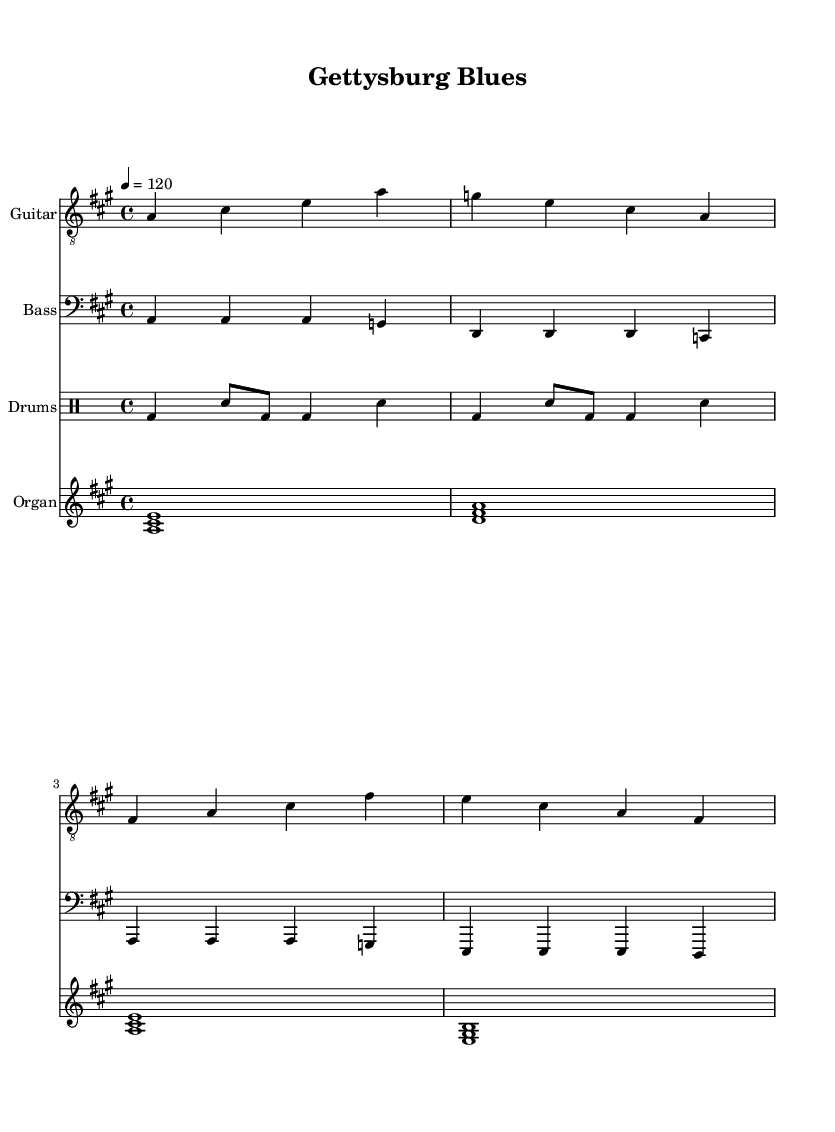What is the key signature of this music? The key signature is A major, which has three sharps: F sharp, C sharp, and G sharp. This is identified by looking at the key signature notation at the beginning of the score.
Answer: A major What is the time signature of this music? The time signature is 4/4, indicated at the beginning of the score. It shows that there are four beats in a measure and the quarter note gets one beat.
Answer: 4/4 What is the tempo marking of this music? The tempo marking is 120 beats per minute, indicated by the tempo text "4 = 120" at the beginning of the score. This refers to the quarter note being played at a speed of 120 beats per minute.
Answer: 120 How many measures are in the guitar part? The guitar part contains 8 measures. This can be counted by examining the stacked vertical lines which denote the end of each measure.
Answer: 8 measures What chord is played in the organ part during the first measure? The chord played is A major, represented by the notes A, C sharp, and E stacked together in the first measure of the organ part. This is identifiable from the notation presented.
Answer: A major Which two military groups are referenced in the lyrics? The lyrics reference Union and Confederate troops, which directly mention the two sides involved in the Battle of Gettysburg. This can be found by reading the provided lyrics beneath the music staff.
Answer: Union and Confederate What type of music does this piece represent? This piece represents Electric Blues, a genre noted for its use of electric instruments, a strong rhythm, and emotional lyrics often tied to themes of struggle and battle. This is drawn from the overall style and instrumentation of the piece presented.
Answer: Electric Blues 